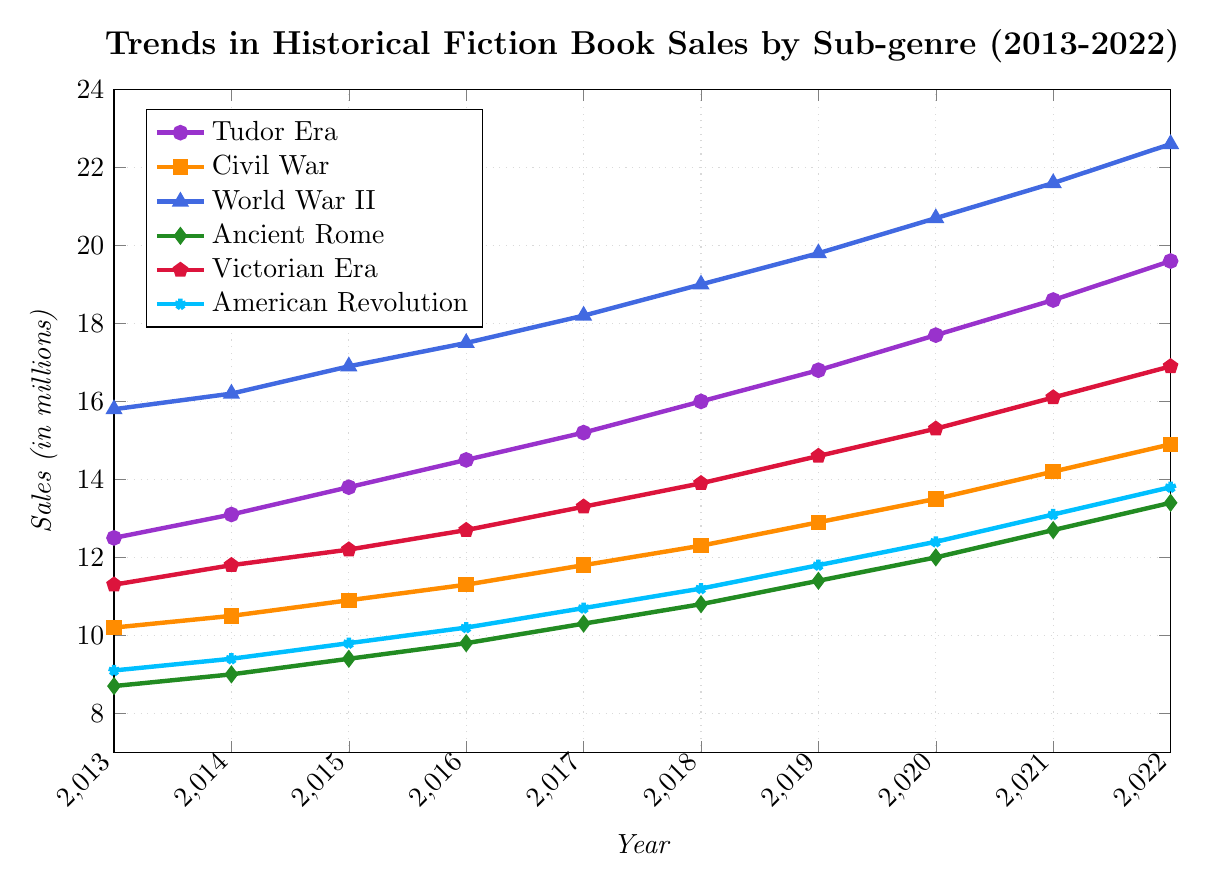What's the trend in sales for the Tudor Era sub-genre from 2013 to 2022? To identify the trend, observe the line representing the Tudor Era from 2013 to 2022. Notice that the values increase each year, indicating a continuous upward trend in sales.
Answer: Increasing Which sub-genre had the highest sales in 2016? Check the values for each sub-genre in 2016. The values are: Tudor Era (14.5), Civil War (11.3), World War II (17.5), Ancient Rome (9.8), Victorian Era (12.7), American Revolution (10.2). The highest value is 17.5 for the World War II sub-genre.
Answer: World War II In which year did the Victorian Era sub-genre surpass 15 million in sales? Look at the values for the Victorian Era sub-genre and find when sales exceed 15 million. This happens in 2020 with sales of 15.3 million.
Answer: 2020 What is the difference in sales between the American Revolution and Ancient Rome sub-genres in 2019? Subtract the sales of Ancient Rome (11.4) from the sales of the American Revolution (11.8) in 2019. The difference is 11.8 - 11.4 = 0.4 million.
Answer: 0.4 million What's the average sales of the Civil War sub-genre over the decade? Sum the sales values of the Civil War sub-genre from 2013 to 2022: 10.2 + 10.5 + 10.9 + 11.3 + 11.8 + 12.3 + 12.9 + 13.5 + 14.2 + 14.9 = 122.5. Divide by 10 years to get the average: 122.5 / 10 = 12.25 million.
Answer: 12.25 million How do sales of the World War II sub-genre compare to the Victorian Era in 2022? Compare the sales values for World War II (22.6) and Victorian Era (16.9). World War II has higher sales than the Victorian Era in 2022.
Answer: World War II has higher sales What color represents the Ancient Rome sub-genre in the chart? Identify the line associated with the Ancient Rome sub-genre and note its color. The Roman Era is represented in green.
Answer: Green What was the total increase in sales for the Tudor Era sub-genre from 2013 to 2022? Calculate the difference between the sales in 2022 (19.6) and 2013 (12.5): 19.6 - 12.5 = 7.1 million.
Answer: 7.1 million 